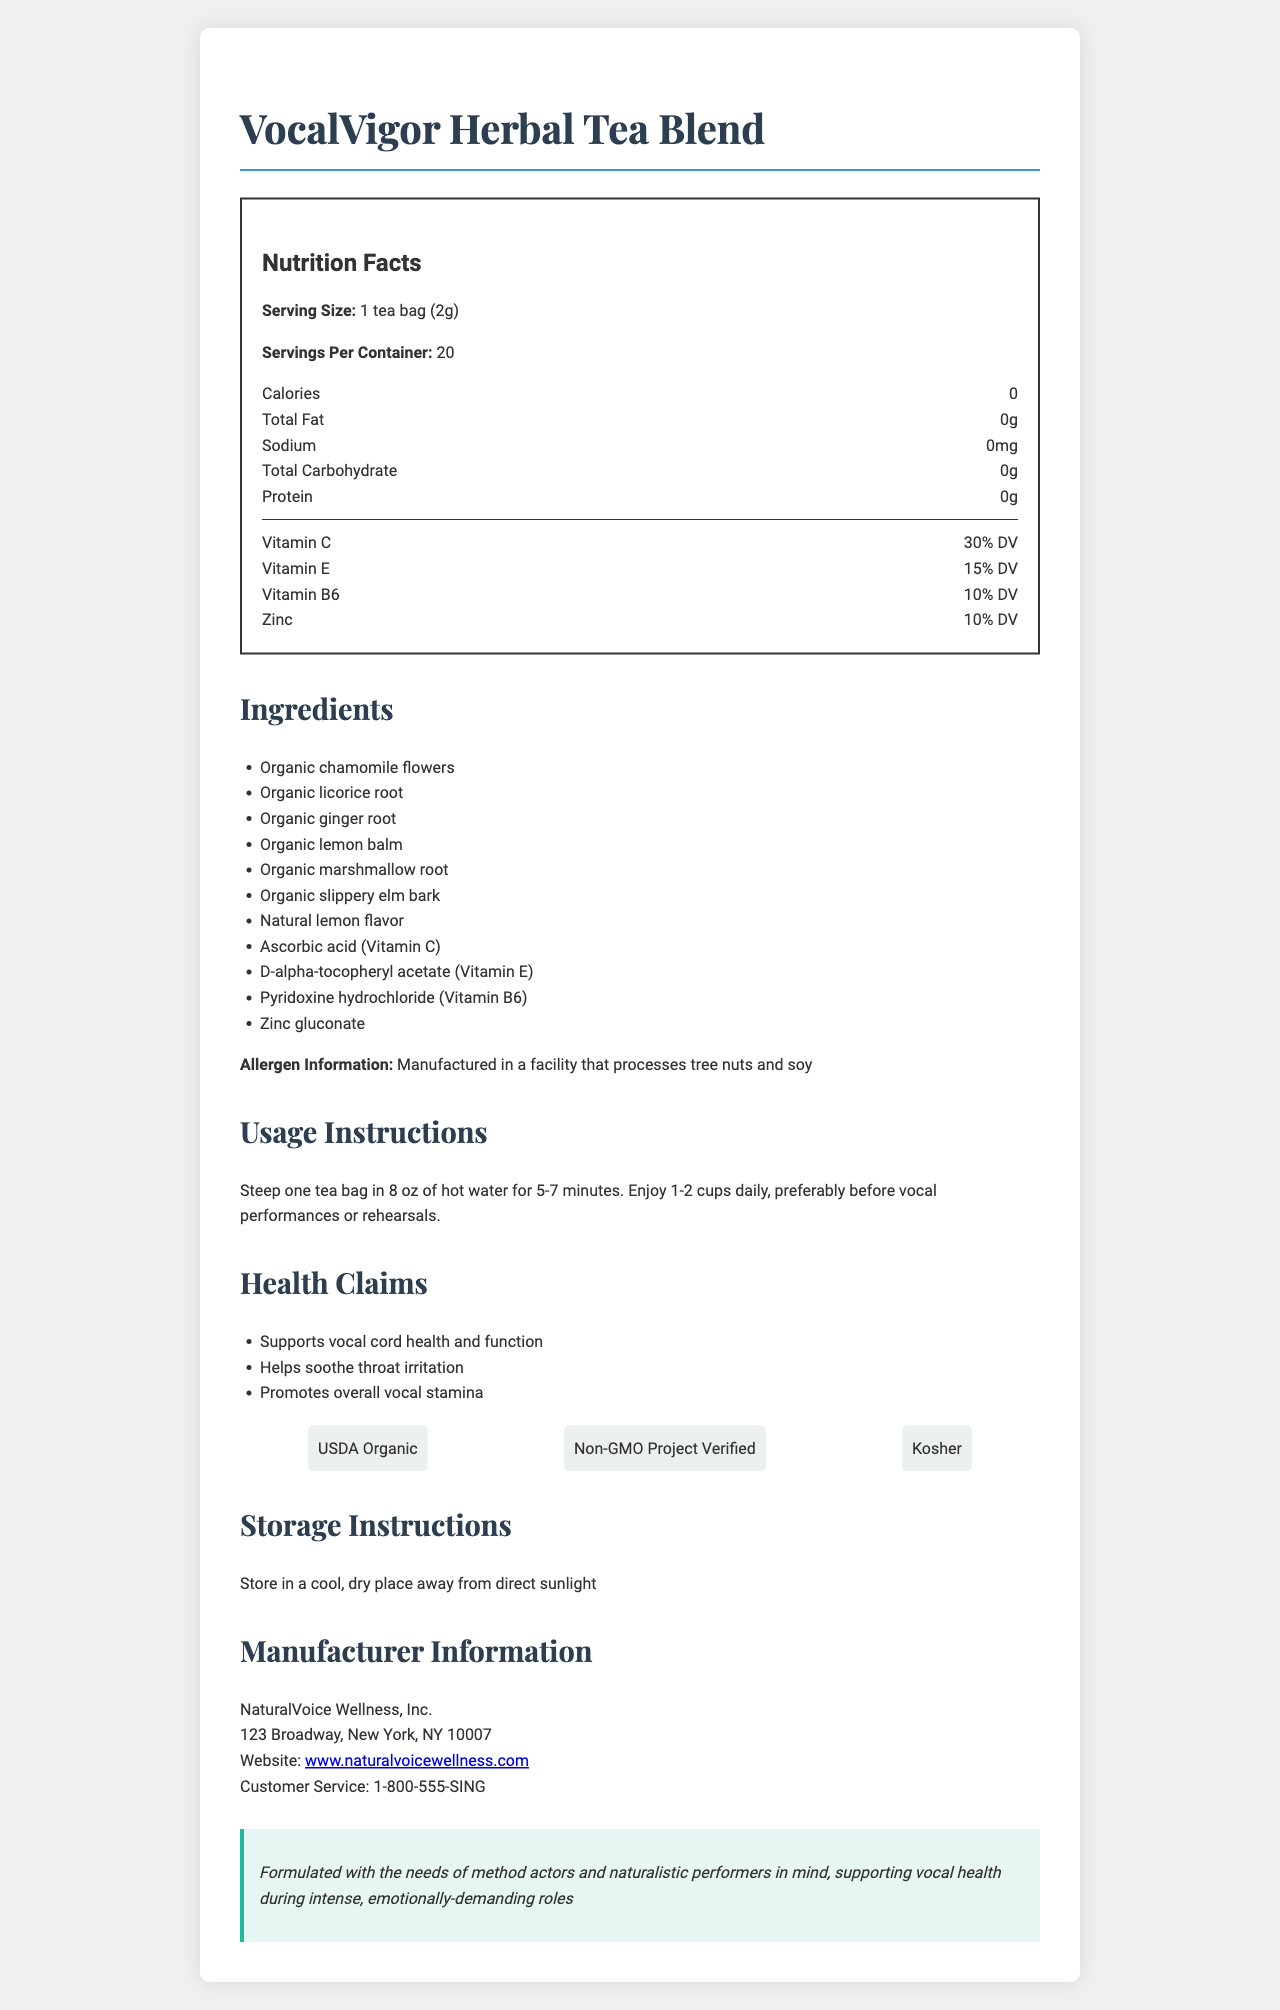how many calories are in a serving size of VocalVigor Herbal Tea Blend? The Nutrition Facts section indicates that there are 0 calories per serving.
Answer: 0 what is the serving size for VocalVigor Herbal Tea Blend? The Nutrition Facts section explicitly mentions that the serving size is 1 tea bag (2g).
Answer: 1 tea bag (2g) what are the vitamins included in the VocalVigor Herbal Tea Blend and their percentages of Daily Value? The Nutrition Facts section lists the vitamins present and their respective percentages of Daily Value (DV).
Answer: Vitamin C: 30% DV, Vitamin E: 15% DV, Vitamin B6: 10% DV, Zinc: 10% DV how many servings are in each container of VocalVigor Herbal Tea Blend? The Nutrition Facts section states that there are 20 servings per container.
Answer: 20 what are the main ingredients in VocalVigor Herbal Tea Blend? The Ingredients section provides a complete list of the ingredients in the tea blend.
Answer: Organic chamomile flowers, Organic licorice root, Organic ginger root, Organic lemon balm, Organic marshmallow root, Organic slippery elm bark, Natural lemon flavor, Ascorbic acid (Vitamin C), D-alpha-tocopheryl acetate (Vitamin E), Pyridoxine hydrochloride (Vitamin B6), Zinc gluconate which of the following certifications does VocalVigor Herbal Tea Blend have? A. USDA Organic B. Non-GMO Project Verified C. Kosher D. All of the above The Certifications section lists USDA Organic, Non-GMO Project Verified, and Kosher, indicating that the tea blend holds all these certifications.
Answer: D. All of the above what is the recommended usage instruction for the tea? A. Steep one tea bag for 8-10 minutes B. Steep one tea bag in 8 oz of hot water for 5-7 minutes C. Drink the tea cold D. Steep one tea bag in cold water for 5-7 minutes The Usage Instructions section recommends steeping one tea bag in 8 oz of hot water for 5-7 minutes.
Answer: B. Steep one tea bag in 8 oz of hot water for 5-7 minutes is the VocalVigor Herbal Tea Blend free from tree nuts and soy? The Allergen Information section notes that the product is manufactured in a facility that processes tree nuts and soy, suggesting it is not free from these allergens.
Answer: No does VocalVigor Herbal Tea Blend support vocal cord health and function? One of the Health Claims explicitly states that the tea supports vocal cord health and function.
Answer: Yes summarize the main idea of the document The document includes comprehensive details about the product and its benefits, emphasizing its suitability for those who rely heavily on their vocal cords.
Answer: The document provides detailed information about VocalVigor Herbal Tea Blend, including its nutritional facts, ingredients, certifications, usage instructions, health claims, storage instructions, and manufacturer information. It highlights that the tea blend is specially formulated to support vocal health and stamina, making it suitable for performers, particularly method actors and naturalistic performers. what is the address of NaturalVoice Wellness, Inc.? The Manufacturer Information section provides the full address of NaturalVoice Wellness, Inc., the manufacturer of the VocalVigor Herbal Tea Blend.
Answer: 123 Broadway, New York, NY 10007 who is the tea blend formulated for according to the acting connection section? The Acting Connection section specifies that the tea blend is formulated with the needs of method actors and naturalistic performers in mind.
Answer: Method actors and naturalistic performers can you determine the price of the VocalVigor Herbal Tea Blend from the document? The document does not provide any information regarding the price of the tea blend.
Answer: Not enough information 